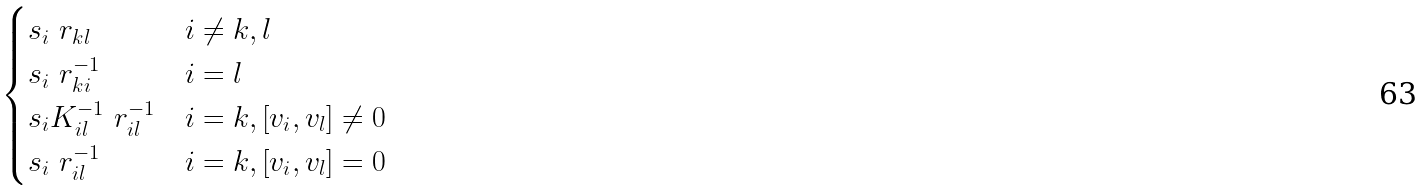<formula> <loc_0><loc_0><loc_500><loc_500>\begin{cases} s _ { i } \ r _ { k l } & i \neq k , l \\ s _ { i } \ r _ { k i } ^ { - 1 } & i = l \\ s _ { i } K _ { i l } ^ { - 1 } \ r _ { i l } ^ { - 1 } & i = k , [ v _ { i } , v _ { l } ] \neq 0 \\ s _ { i } \ r _ { i l } ^ { - 1 } & i = k , [ v _ { i } , v _ { l } ] = 0 \end{cases}</formula> 